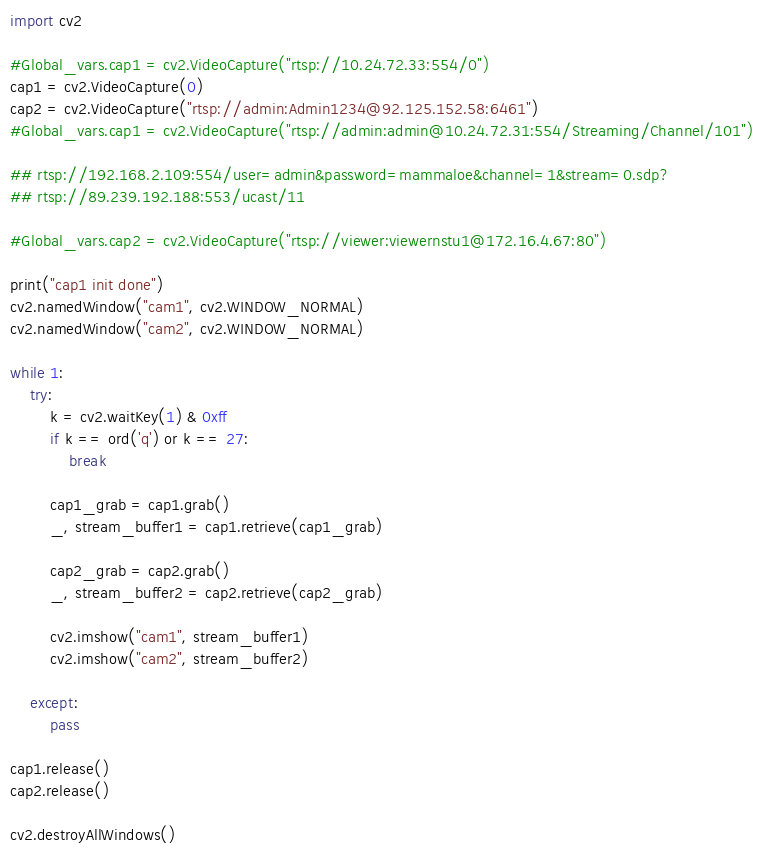Convert code to text. <code><loc_0><loc_0><loc_500><loc_500><_Python_>import cv2

#Global_vars.cap1 = cv2.VideoCapture("rtsp://10.24.72.33:554/0")
cap1 = cv2.VideoCapture(0)
cap2 = cv2.VideoCapture("rtsp://admin:Admin1234@92.125.152.58:6461")
#Global_vars.cap1 = cv2.VideoCapture("rtsp://admin:admin@10.24.72.31:554/Streaming/Channel/101")

## rtsp://192.168.2.109:554/user=admin&password=mammaloe&channel=1&stream=0.sdp?
## rtsp://89.239.192.188:553/ucast/11

#Global_vars.cap2 = cv2.VideoCapture("rtsp://viewer:viewernstu1@172.16.4.67:80")

print("cap1 init done")
cv2.namedWindow("cam1", cv2.WINDOW_NORMAL) 
cv2.namedWindow("cam2", cv2.WINDOW_NORMAL) 

while 1:
    try:
        k = cv2.waitKey(1) & 0xff
        if k == ord('q') or k == 27:
            break
        
        cap1_grab = cap1.grab()
        _, stream_buffer1 = cap1.retrieve(cap1_grab)

        cap2_grab = cap2.grab()
        _, stream_buffer2 = cap2.retrieve(cap2_grab)

        cv2.imshow("cam1", stream_buffer1)
        cv2.imshow("cam2", stream_buffer2)

    except:
        pass

cap1.release()
cap2.release()

cv2.destroyAllWindows()</code> 